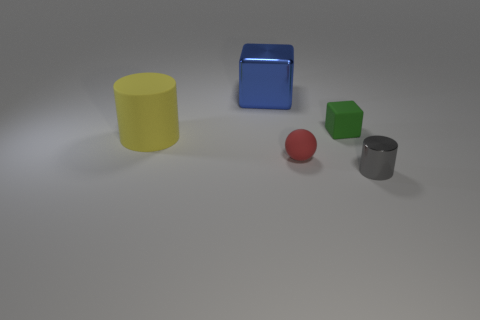Subtract all green cubes. How many cubes are left? 1 Add 4 tiny gray shiny cylinders. How many objects exist? 9 Subtract 1 balls. How many balls are left? 0 Subtract all blocks. How many objects are left? 3 Subtract all purple cylinders. How many red blocks are left? 0 Add 2 large yellow things. How many large yellow things exist? 3 Subtract 0 gray balls. How many objects are left? 5 Subtract all cyan cylinders. Subtract all gray blocks. How many cylinders are left? 2 Subtract all tiny cylinders. Subtract all gray cylinders. How many objects are left? 3 Add 5 tiny matte things. How many tiny matte things are left? 7 